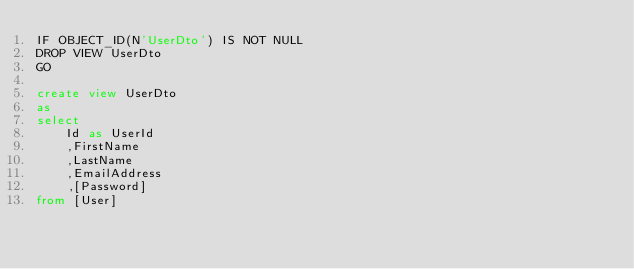Convert code to text. <code><loc_0><loc_0><loc_500><loc_500><_SQL_>IF OBJECT_ID(N'UserDto') IS NOT NULL
DROP VIEW UserDto
GO

create view UserDto
as
select 
	Id as UserId
	,FirstName
	,LastName
	,EmailAddress
	,[Password]
from [User]
</code> 